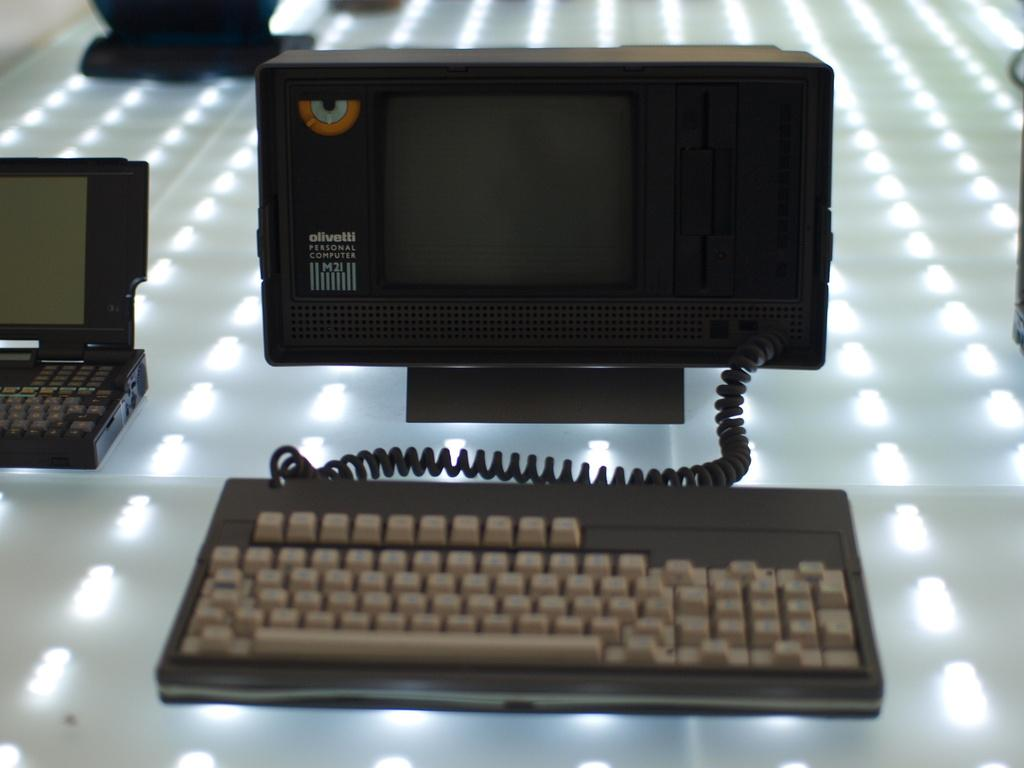Provide a one-sentence caption for the provided image. An Olivetti Personal Computer M2I small personal computer. 